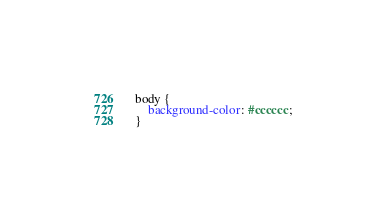<code> <loc_0><loc_0><loc_500><loc_500><_CSS_> body {
     background-color: #cccccc;
 }</code> 